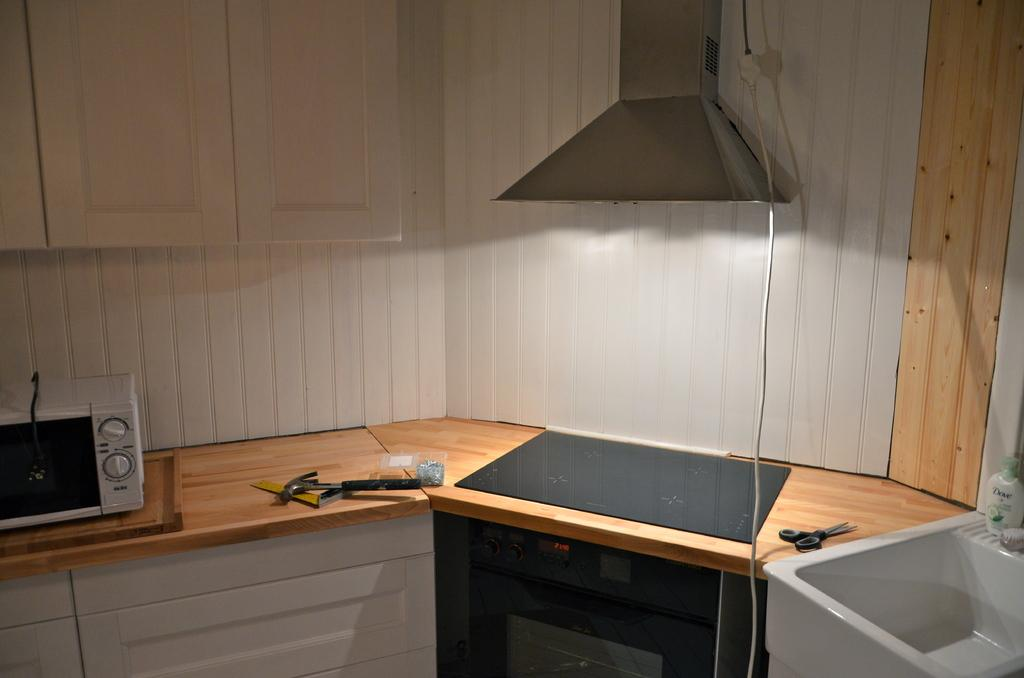What tools are present in the image? There is a hammer and a pair of scissors in the image. What objects are present in the image that are not tools? There is a box, a light, and a microwave in the image. Can you describe the light in the image? The light is likely an overhead light or a lamp, providing illumination to the area. What type of appliance is present in the image? There is a microwave in the image, which is an appliance used for heating food. How does the earthquake affect the tools in the image? There is no earthquake present in the image, so its effects on the tools cannot be determined. 